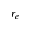<formula> <loc_0><loc_0><loc_500><loc_500>r _ { e }</formula> 